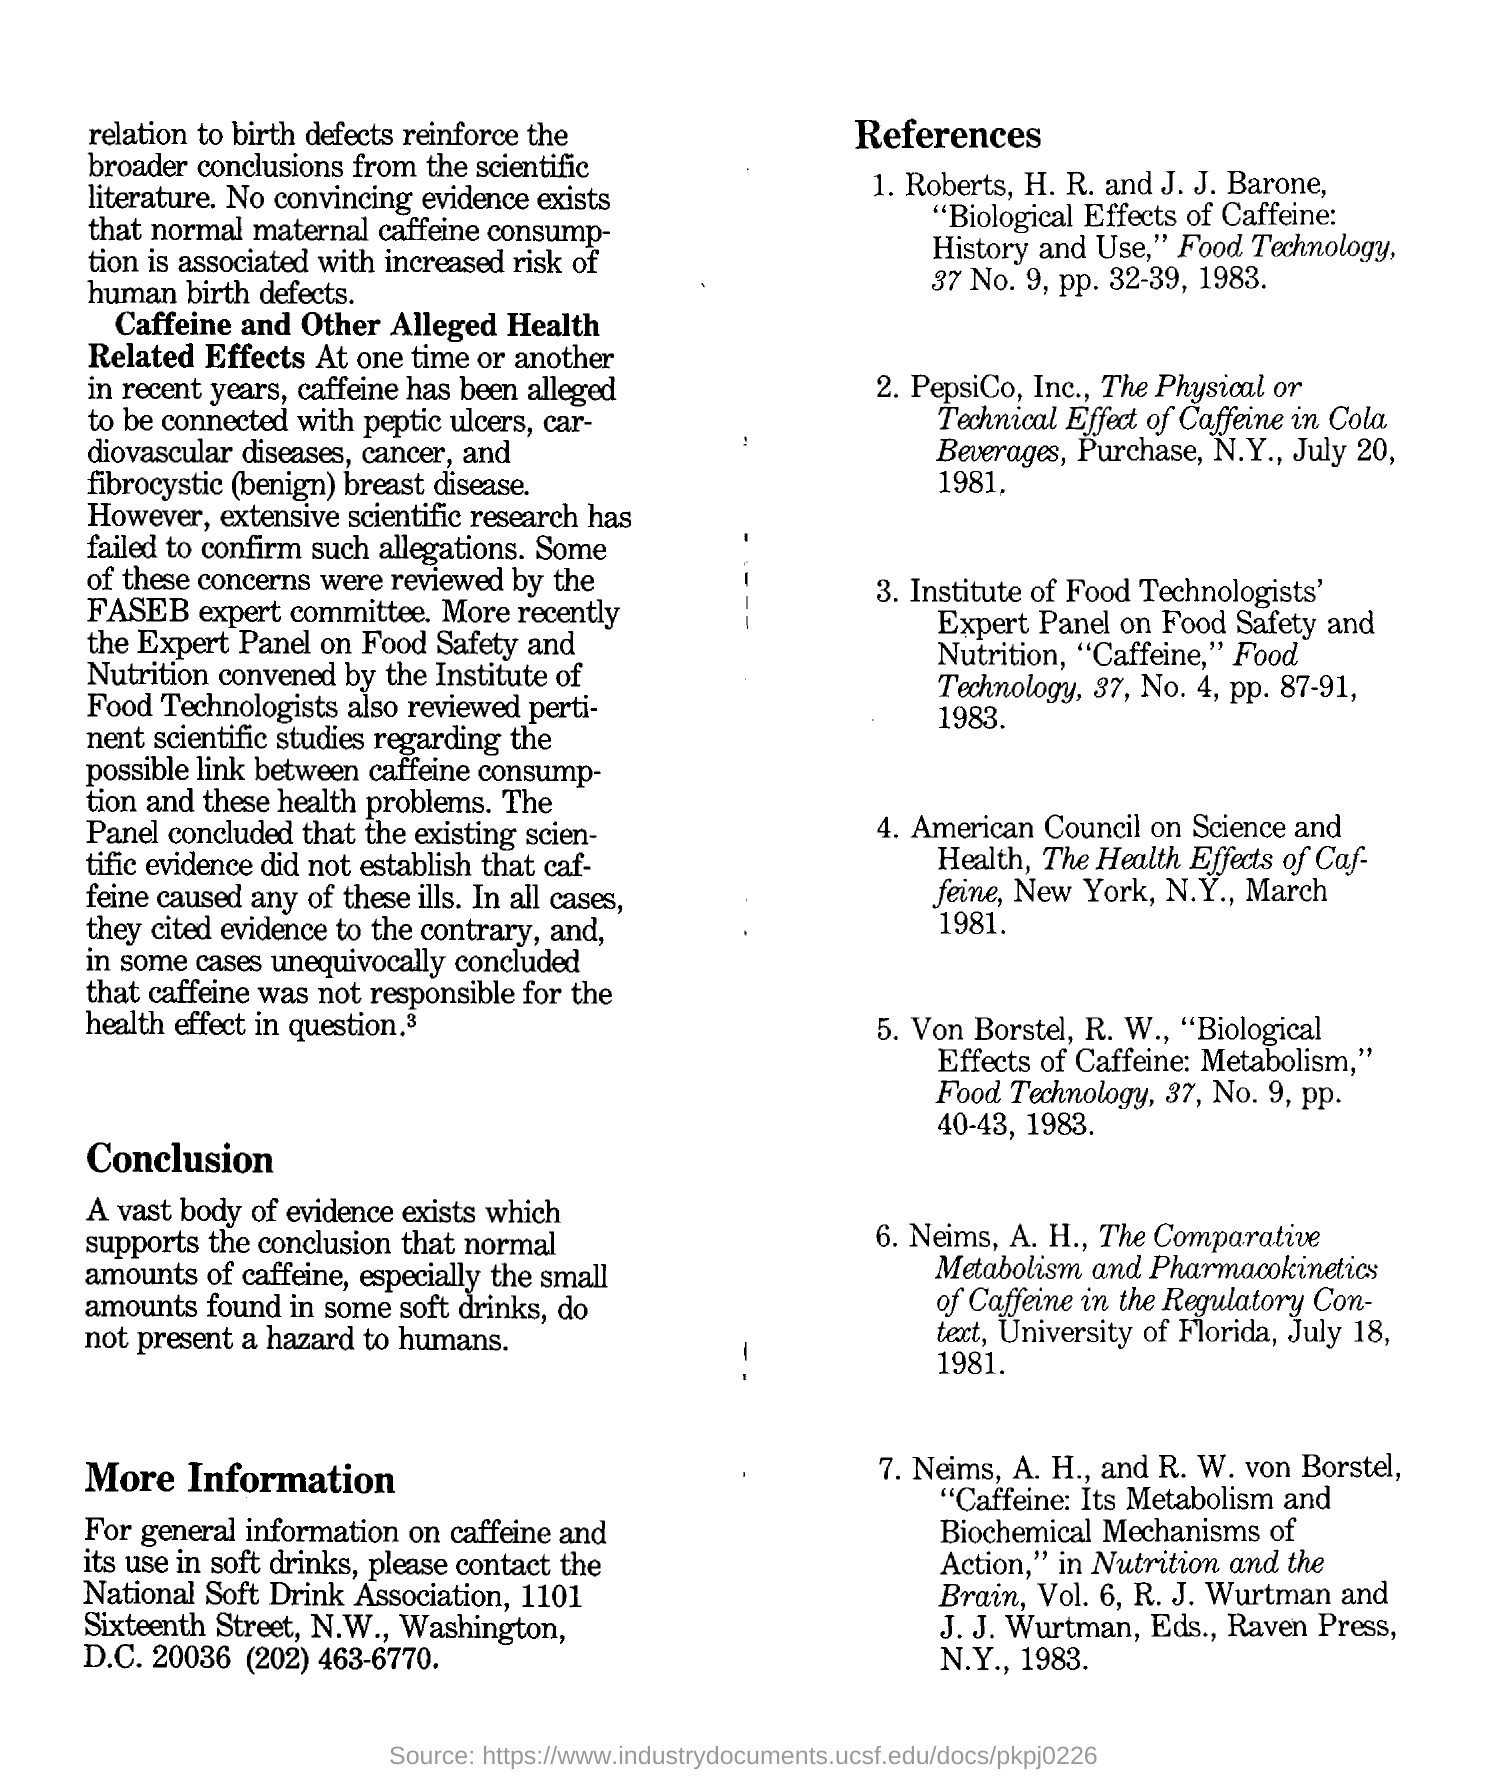What is are the words written in bold in second paragraph?
Give a very brief answer. Caffeine and Other Alleged Health Related Effects. What is the second reference mentioned?
Keep it short and to the point. PepsiCo, Inc., The Physical or Technical Effect of Caffeine in Cola Beverages, Purchase, N.Y., July 20, 1981. Which university does the sixth reference mention?
Keep it short and to the point. University of Florida. Which year is mentioned in the first reference?
Keep it short and to the point. 1983. 